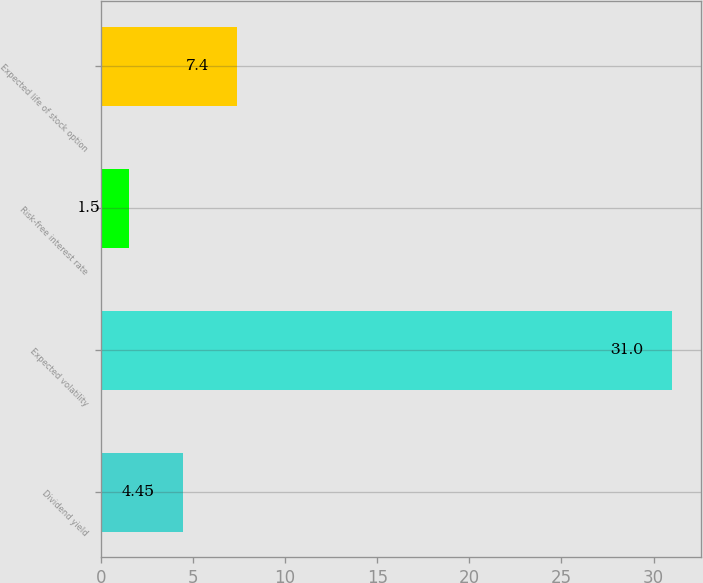<chart> <loc_0><loc_0><loc_500><loc_500><bar_chart><fcel>Dividend yield<fcel>Expected volatility<fcel>Risk-free interest rate<fcel>Expected life of stock option<nl><fcel>4.45<fcel>31<fcel>1.5<fcel>7.4<nl></chart> 